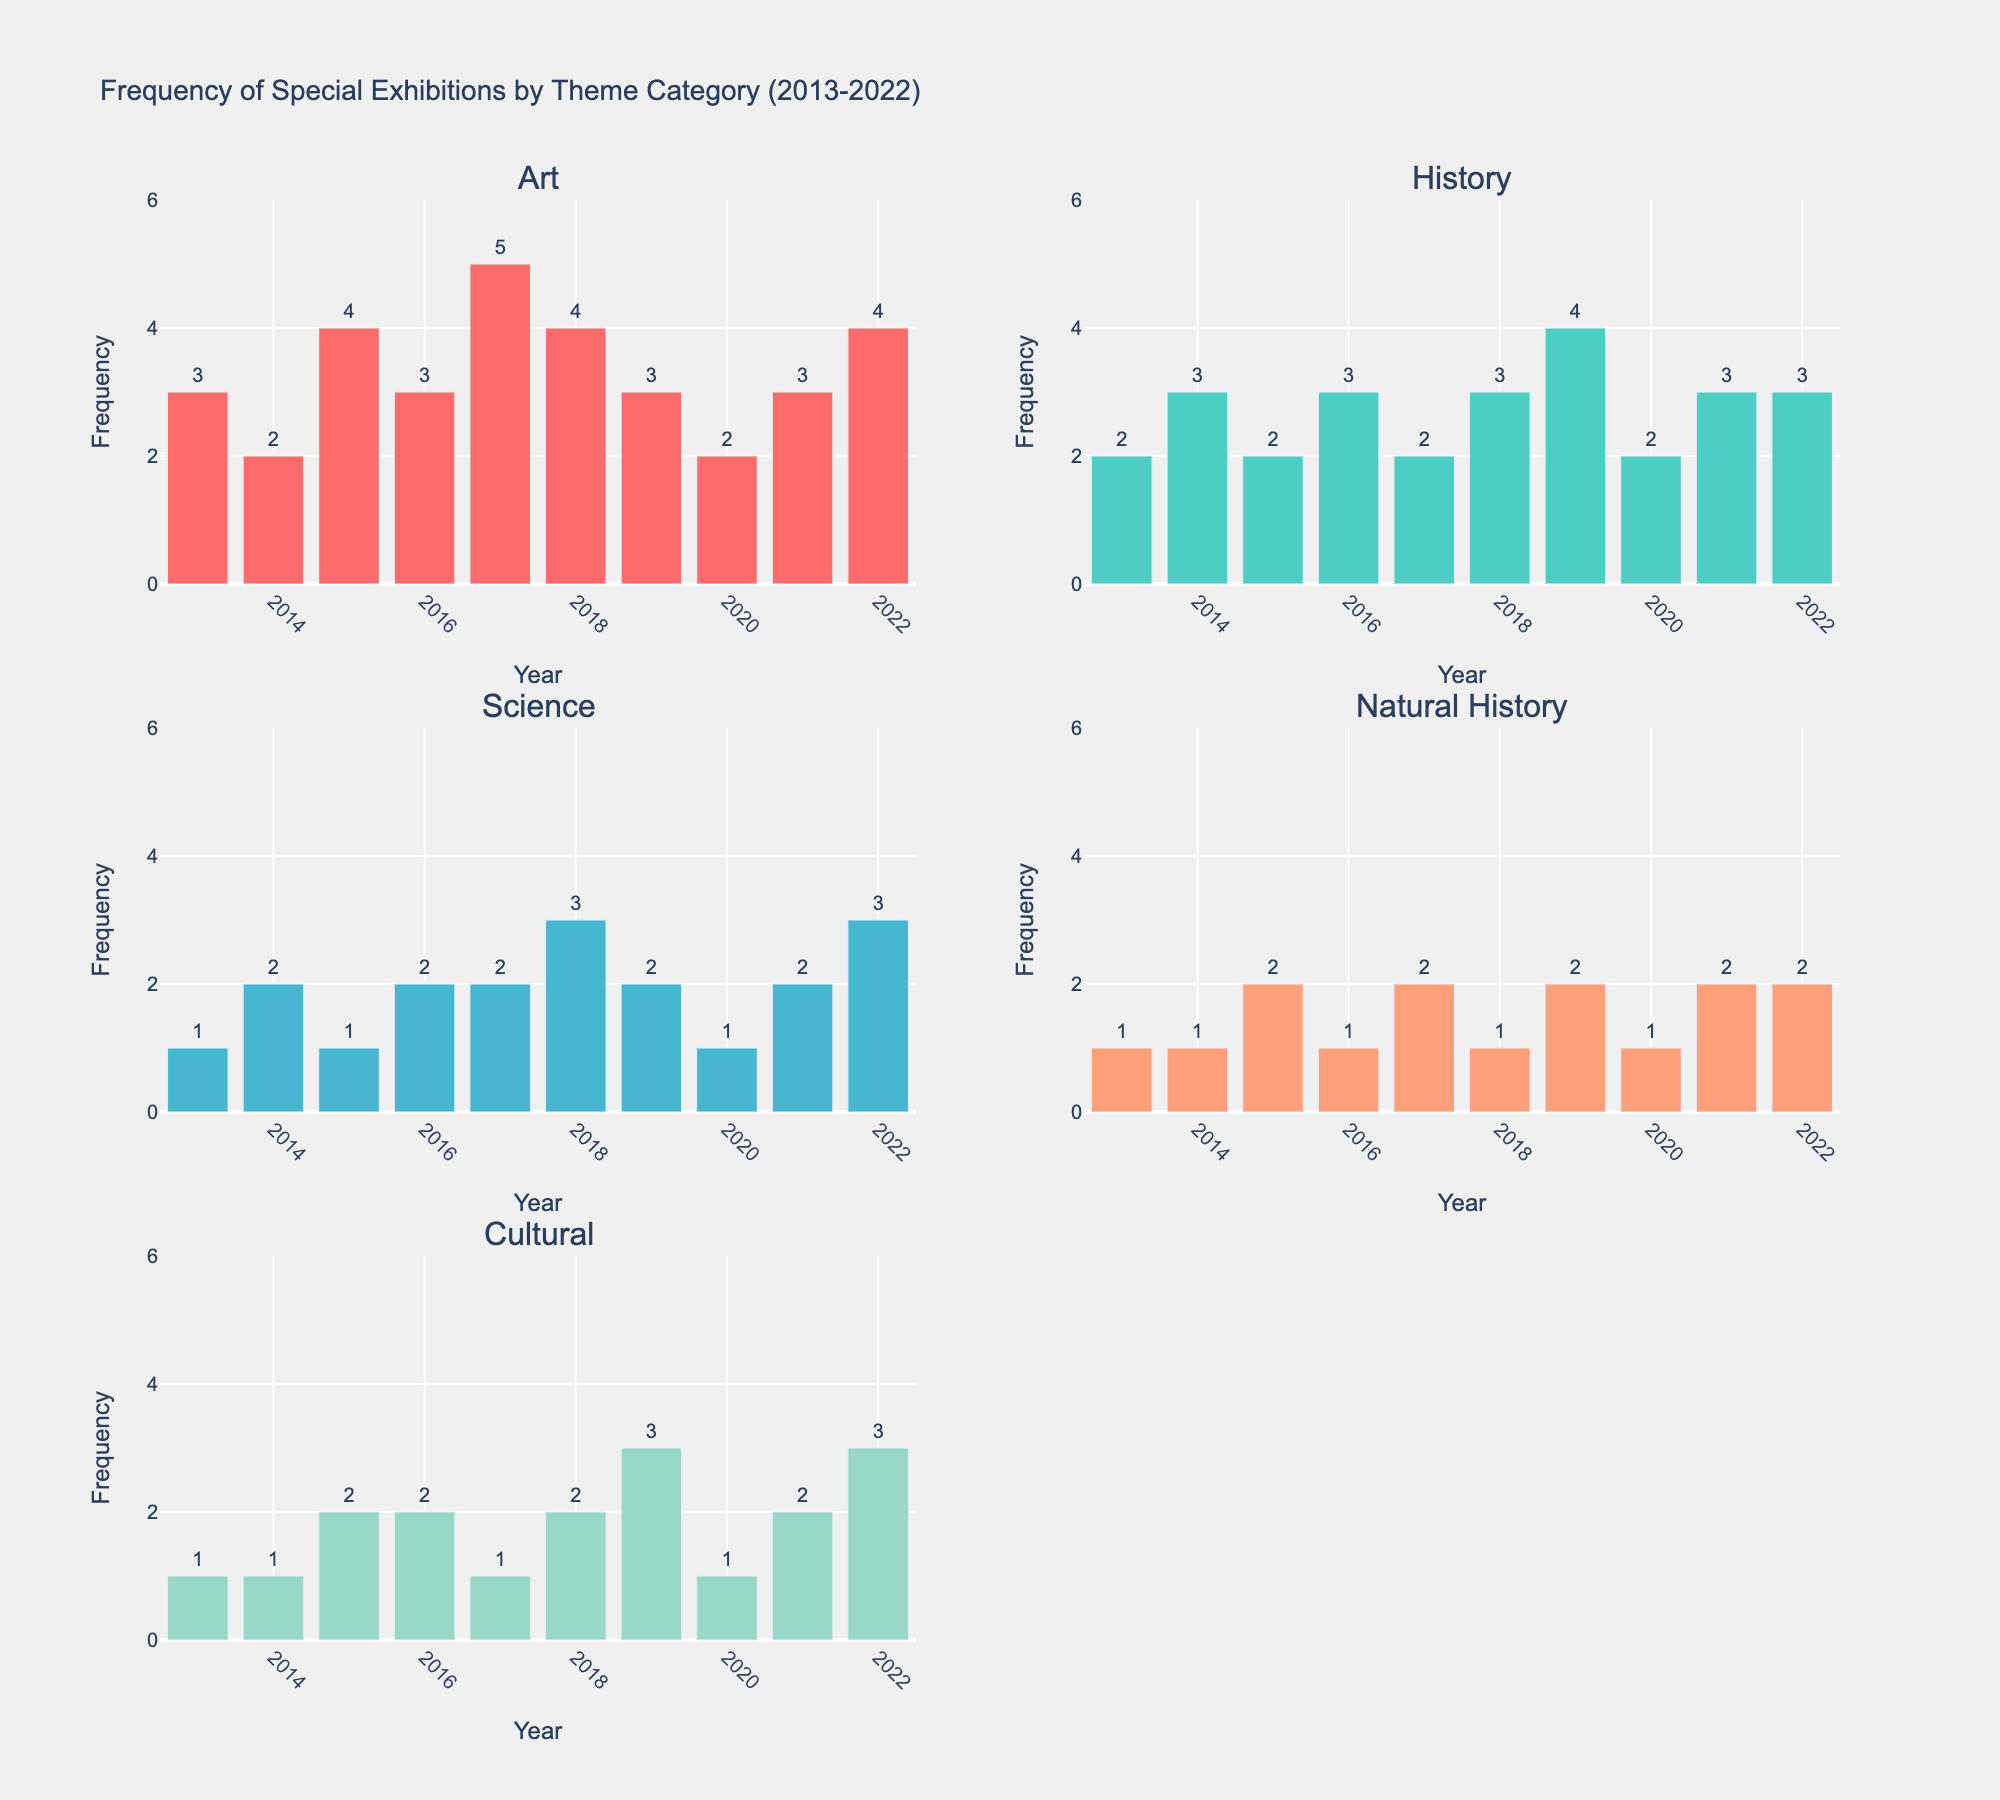What is the title of the figure? The title of the figure is displayed at the top and typically summarizes what the figure is about. In this case, it states "Frequency of Special Exhibitions by Theme Category (2013-2022)."
Answer: Frequency of Special Exhibitions by Theme Category (2013-2022) Which year had the highest number of 'Art' exhibitions? To answer this, we need to look at the 'Art' subplot and find the highest bar and its corresponding year. The 'Art' bar chart shows that the year 2017 has the highest frequency with a value of 5.
Answer: 2017 How many 'Science' exhibitions were there in 2018? We need to locate the 'Science' subplot and find the bar corresponding to the year 2018. The 'Science' exhibitions count in 2018 is 3.
Answer: 3 How does the number of 'History' exhibitions in 2019 compare to 2020? To compare these, we find the bars for 'History' in the years 2019 and 2020. In 2019, there were 4 exhibitions, and in 2020, there were 2.
Answer: 2019 had more exhibitions (4 vs 2) What is the average number of 'Cultural' exhibitions over the last decade? To find the average, sum the 'Cultural' exhibition counts from 2013 to 2022 and then divide by the number of years (10). Sum: 1+1+2+2+1+2+3+1+2+3 = 18, so the average is 18/10 = 1.8
Answer: 1.8 Which category had the most consistent number of exhibitions over the years? "Consistent" here means the least variation year over year. Observing the subplots, 'Natural History' had values ranging mostly between 1 and 2, indicating the least variation.
Answer: Natural History Sum the number of 'Art' and 'Science' exhibitions in 2015. We need to locate the bars for the year 2015 in both the 'Art' and 'Science' subplots. 'Art' has 4 exhibitions and 'Science' has 1. The sum is 4 + 1 = 5.
Answer: 5 In which year did 'History' exhibitions see their peak, and how many were there? Checking the 'History' subplot, the year with the highest frequency is 2019 with 4 exhibitions.
Answer: 2019, 4 What is the difference between the 'Natural History' exhibitions in 2016 and 2019? The 'Natural History' exhibitions count was 1 in 2016 and 2 in 2019. The difference is 2 - 1 = 1.
Answer: 1 How many categories had their highest number of exhibitions in 2022? By examining each subplot for their peak in 2022, we see that 'Science', 'Natural History', and 'Cultural' have their highest frequencies in 2022. So, there are 3 categories.
Answer: 3 